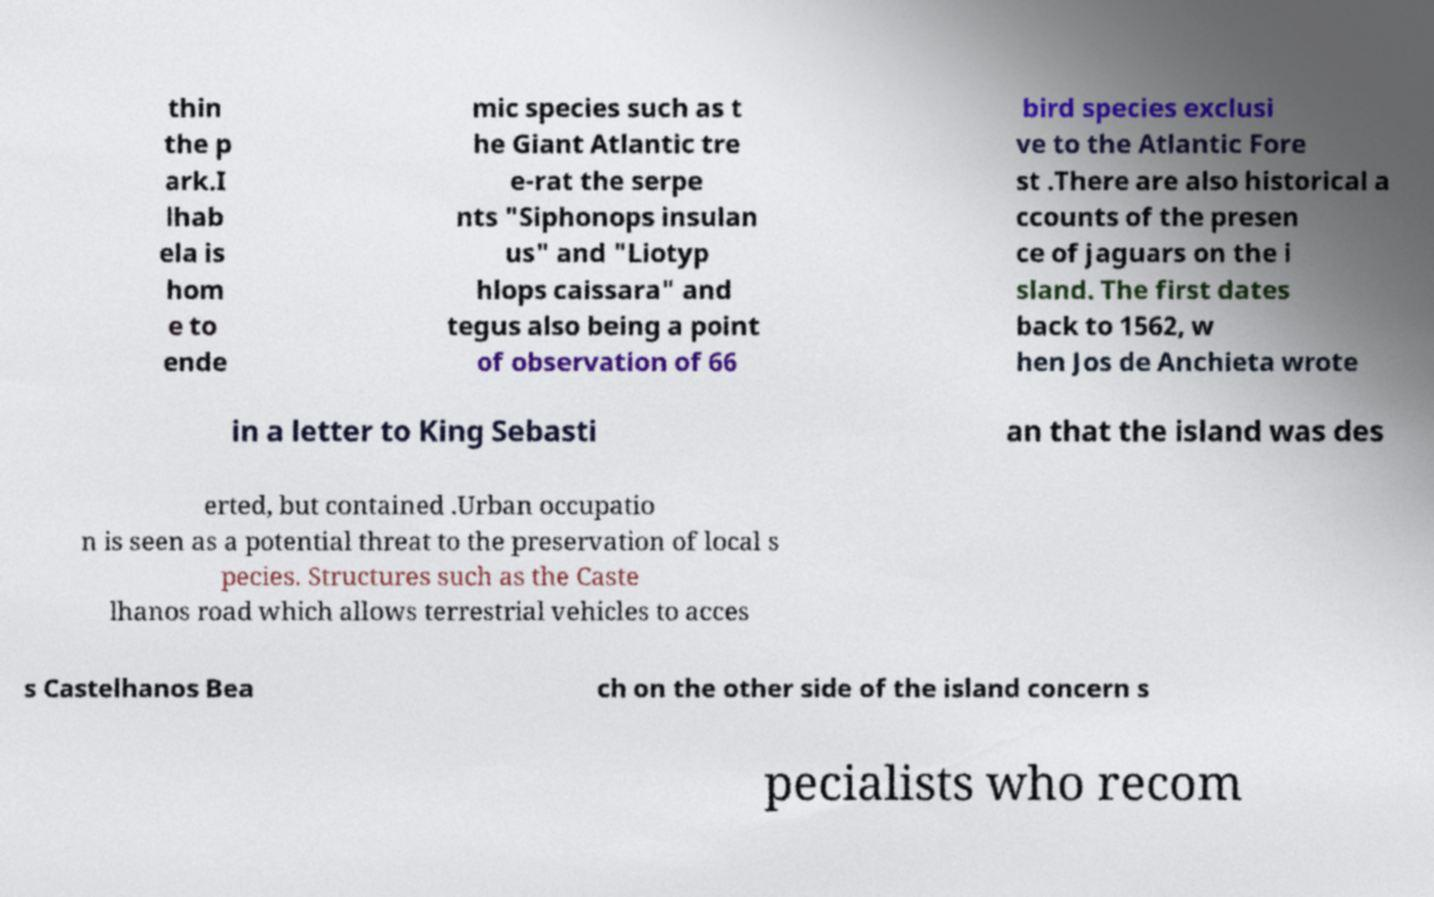Could you extract and type out the text from this image? thin the p ark.I lhab ela is hom e to ende mic species such as t he Giant Atlantic tre e-rat the serpe nts "Siphonops insulan us" and "Liotyp hlops caissara" and tegus also being a point of observation of 66 bird species exclusi ve to the Atlantic Fore st .There are also historical a ccounts of the presen ce of jaguars on the i sland. The first dates back to 1562, w hen Jos de Anchieta wrote in a letter to King Sebasti an that the island was des erted, but contained .Urban occupatio n is seen as a potential threat to the preservation of local s pecies. Structures such as the Caste lhanos road which allows terrestrial vehicles to acces s Castelhanos Bea ch on the other side of the island concern s pecialists who recom 